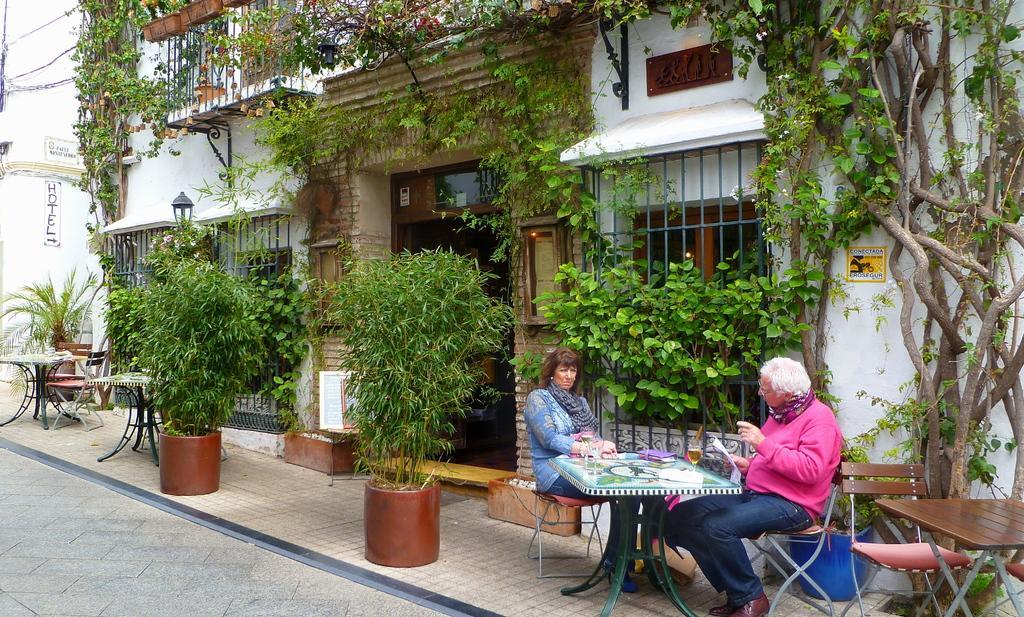Can you describe this image briefly? This picture shows a house and we see plants and two people seated on the chair and we see a table 